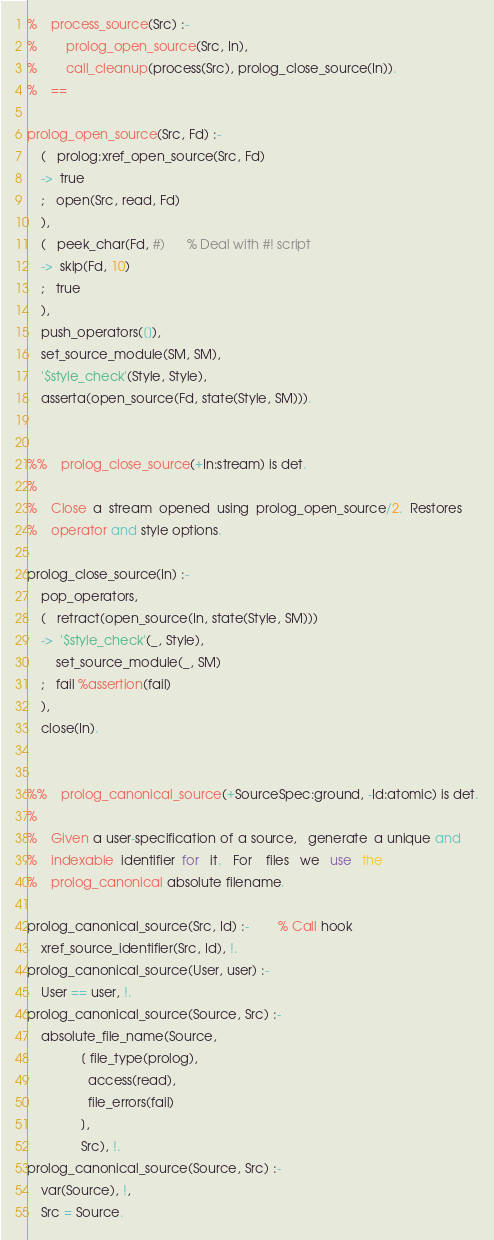Convert code to text. <code><loc_0><loc_0><loc_500><loc_500><_Perl_>%	process_source(Src) :-
%		prolog_open_source(Src, In),
%		call_cleanup(process(Src), prolog_close_source(In)).
%	==

prolog_open_source(Src, Fd) :-
	(   prolog:xref_open_source(Src, Fd)
	->  true
	;   open(Src, read, Fd)
	),
	(   peek_char(Fd, #)		% Deal with #! script
	->  skip(Fd, 10)
	;   true
	),
	push_operators([]),
	set_source_module(SM, SM),
	'$style_check'(Style, Style),
	asserta(open_source(Fd, state(Style, SM))).


%%	prolog_close_source(+In:stream) is det.
%
%	Close  a  stream  opened  using  prolog_open_source/2.  Restores
%	operator and style options.

prolog_close_source(In) :-
	pop_operators,
	(   retract(open_source(In, state(Style, SM)))
	->  '$style_check'(_, Style),
	    set_source_module(_, SM)
	;   fail %assertion(fail)
	),
	close(In).


%%	prolog_canonical_source(+SourceSpec:ground, -Id:atomic) is det.
%	
%	Given a user-specification of a source,   generate  a unique and
%	indexable  identifier  for   it.   For    files   we   use   the
%	prolog_canonical absolute filename.

prolog_canonical_source(Src, Id) :-		% Call hook
	xref_source_identifier(Src, Id), !.
prolog_canonical_source(User, user) :-
	User == user, !.
prolog_canonical_source(Source, Src) :-
	absolute_file_name(Source,
			   [ file_type(prolog),
			     access(read),
			     file_errors(fail)
			   ],
			   Src), !.
prolog_canonical_source(Source, Src) :-
	var(Source), !,
	Src = Source.
</code> 